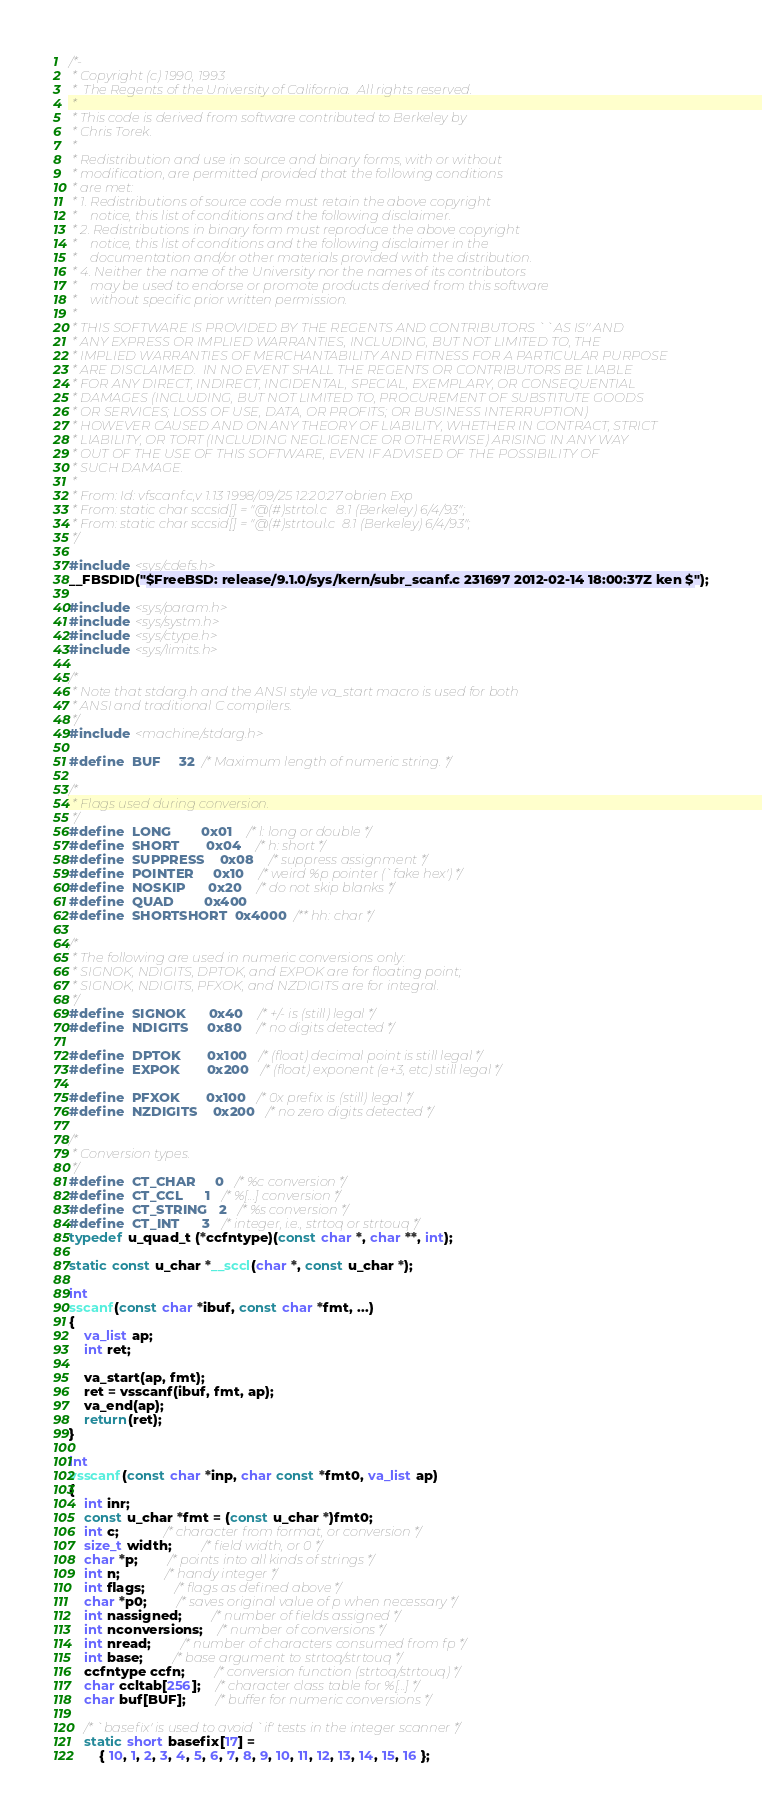Convert code to text. <code><loc_0><loc_0><loc_500><loc_500><_C_>/*-
 * Copyright (c) 1990, 1993
 *	The Regents of the University of California.  All rights reserved.
 *
 * This code is derived from software contributed to Berkeley by
 * Chris Torek.
 *
 * Redistribution and use in source and binary forms, with or without
 * modification, are permitted provided that the following conditions
 * are met:
 * 1. Redistributions of source code must retain the above copyright
 *    notice, this list of conditions and the following disclaimer.
 * 2. Redistributions in binary form must reproduce the above copyright
 *    notice, this list of conditions and the following disclaimer in the
 *    documentation and/or other materials provided with the distribution.
 * 4. Neither the name of the University nor the names of its contributors
 *    may be used to endorse or promote products derived from this software
 *    without specific prior written permission.
 *
 * THIS SOFTWARE IS PROVIDED BY THE REGENTS AND CONTRIBUTORS ``AS IS'' AND
 * ANY EXPRESS OR IMPLIED WARRANTIES, INCLUDING, BUT NOT LIMITED TO, THE
 * IMPLIED WARRANTIES OF MERCHANTABILITY AND FITNESS FOR A PARTICULAR PURPOSE
 * ARE DISCLAIMED.  IN NO EVENT SHALL THE REGENTS OR CONTRIBUTORS BE LIABLE
 * FOR ANY DIRECT, INDIRECT, INCIDENTAL, SPECIAL, EXEMPLARY, OR CONSEQUENTIAL
 * DAMAGES (INCLUDING, BUT NOT LIMITED TO, PROCUREMENT OF SUBSTITUTE GOODS
 * OR SERVICES; LOSS OF USE, DATA, OR PROFITS; OR BUSINESS INTERRUPTION)
 * HOWEVER CAUSED AND ON ANY THEORY OF LIABILITY, WHETHER IN CONTRACT, STRICT
 * LIABILITY, OR TORT (INCLUDING NEGLIGENCE OR OTHERWISE) ARISING IN ANY WAY
 * OUT OF THE USE OF THIS SOFTWARE, EVEN IF ADVISED OF THE POSSIBILITY OF
 * SUCH DAMAGE.
 *
 * From: Id: vfscanf.c,v 1.13 1998/09/25 12:20:27 obrien Exp 
 * From: static char sccsid[] = "@(#)strtol.c	8.1 (Berkeley) 6/4/93";
 * From: static char sccsid[] = "@(#)strtoul.c	8.1 (Berkeley) 6/4/93";
 */

#include <sys/cdefs.h>
__FBSDID("$FreeBSD: release/9.1.0/sys/kern/subr_scanf.c 231697 2012-02-14 18:00:37Z ken $");

#include <sys/param.h>
#include <sys/systm.h>
#include <sys/ctype.h>
#include <sys/limits.h>

/*
 * Note that stdarg.h and the ANSI style va_start macro is used for both
 * ANSI and traditional C compilers.
 */
#include <machine/stdarg.h>

#define	BUF		32 	/* Maximum length of numeric string. */

/*
 * Flags used during conversion.
 */
#define	LONG		0x01	/* l: long or double */
#define	SHORT		0x04	/* h: short */
#define	SUPPRESS	0x08	/* suppress assignment */
#define	POINTER		0x10	/* weird %p pointer (`fake hex') */
#define	NOSKIP		0x20	/* do not skip blanks */
#define	QUAD		0x400
#define	SHORTSHORT	0x4000	/** hh: char */

/*
 * The following are used in numeric conversions only:
 * SIGNOK, NDIGITS, DPTOK, and EXPOK are for floating point;
 * SIGNOK, NDIGITS, PFXOK, and NZDIGITS are for integral.
 */
#define	SIGNOK		0x40	/* +/- is (still) legal */
#define	NDIGITS		0x80	/* no digits detected */

#define	DPTOK		0x100	/* (float) decimal point is still legal */
#define	EXPOK		0x200	/* (float) exponent (e+3, etc) still legal */

#define	PFXOK		0x100	/* 0x prefix is (still) legal */
#define	NZDIGITS	0x200	/* no zero digits detected */

/*
 * Conversion types.
 */
#define	CT_CHAR		0	/* %c conversion */
#define	CT_CCL		1	/* %[...] conversion */
#define	CT_STRING	2	/* %s conversion */
#define	CT_INT		3	/* integer, i.e., strtoq or strtouq */
typedef u_quad_t (*ccfntype)(const char *, char **, int);

static const u_char *__sccl(char *, const u_char *);

int
sscanf(const char *ibuf, const char *fmt, ...)
{
	va_list ap;
	int ret;
	
	va_start(ap, fmt);
	ret = vsscanf(ibuf, fmt, ap);
	va_end(ap);
	return(ret);
}

int
vsscanf(const char *inp, char const *fmt0, va_list ap)
{
	int inr;
	const u_char *fmt = (const u_char *)fmt0;
	int c;			/* character from format, or conversion */
	size_t width;		/* field width, or 0 */
	char *p;		/* points into all kinds of strings */
	int n;			/* handy integer */
	int flags;		/* flags as defined above */
	char *p0;		/* saves original value of p when necessary */
	int nassigned;		/* number of fields assigned */
	int nconversions;	/* number of conversions */
	int nread;		/* number of characters consumed from fp */
	int base;		/* base argument to strtoq/strtouq */
	ccfntype ccfn;		/* conversion function (strtoq/strtouq) */
	char ccltab[256];	/* character class table for %[...] */
	char buf[BUF];		/* buffer for numeric conversions */

	/* `basefix' is used to avoid `if' tests in the integer scanner */
	static short basefix[17] =
		{ 10, 1, 2, 3, 4, 5, 6, 7, 8, 9, 10, 11, 12, 13, 14, 15, 16 };
</code> 